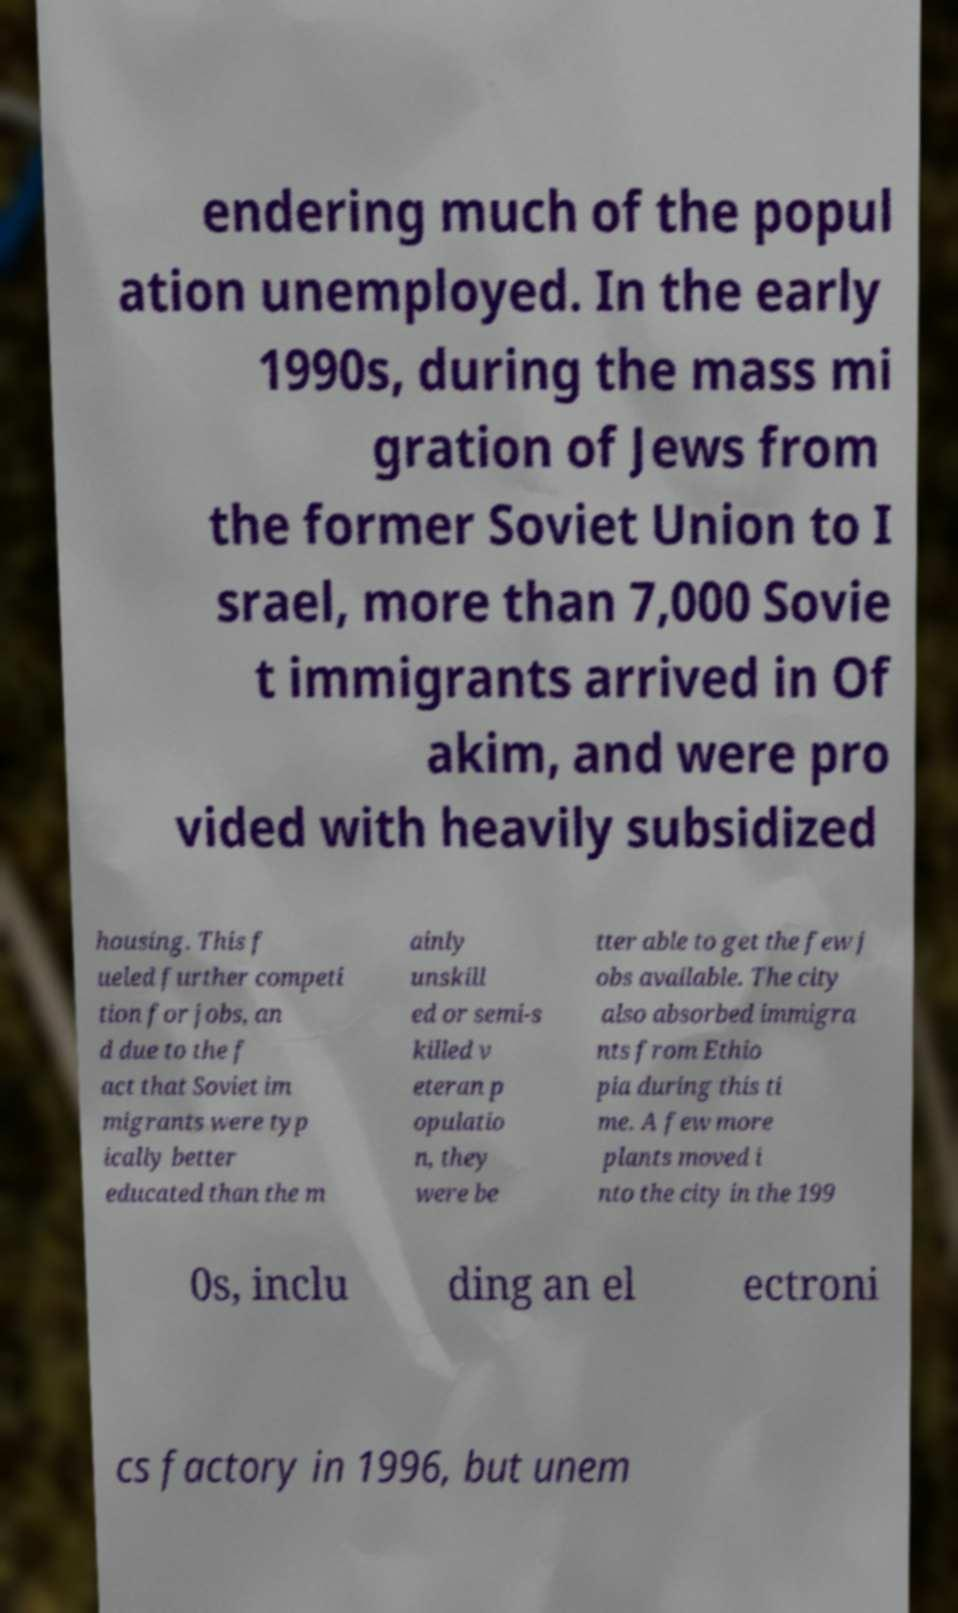Please read and relay the text visible in this image. What does it say? endering much of the popul ation unemployed. In the early 1990s, during the mass mi gration of Jews from the former Soviet Union to I srael, more than 7,000 Sovie t immigrants arrived in Of akim, and were pro vided with heavily subsidized housing. This f ueled further competi tion for jobs, an d due to the f act that Soviet im migrants were typ ically better educated than the m ainly unskill ed or semi-s killed v eteran p opulatio n, they were be tter able to get the few j obs available. The city also absorbed immigra nts from Ethio pia during this ti me. A few more plants moved i nto the city in the 199 0s, inclu ding an el ectroni cs factory in 1996, but unem 